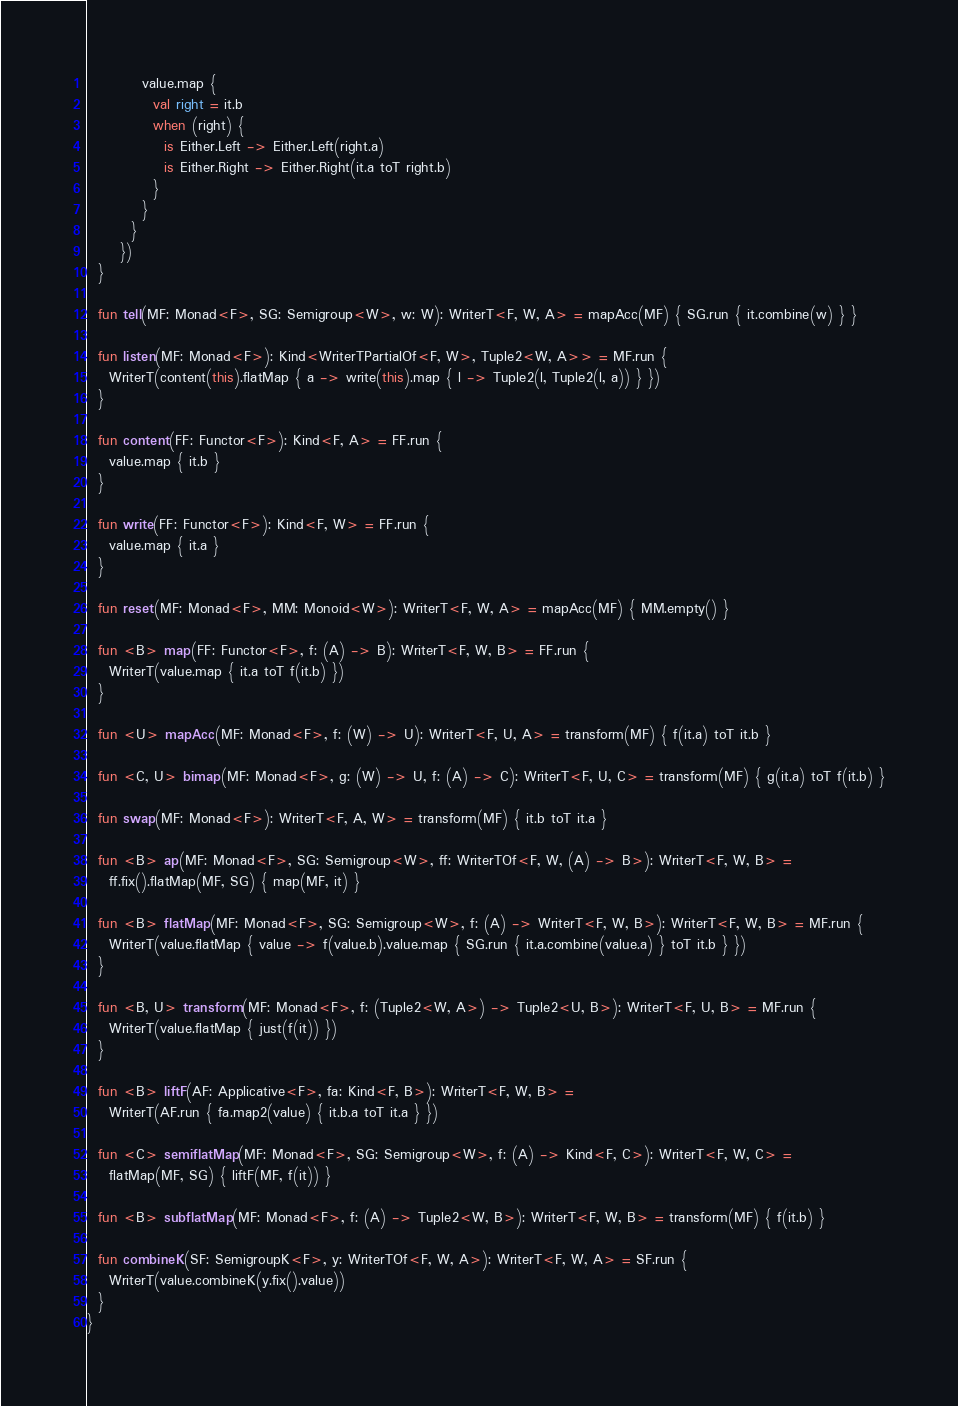<code> <loc_0><loc_0><loc_500><loc_500><_Kotlin_>          value.map {
            val right = it.b
            when (right) {
              is Either.Left -> Either.Left(right.a)
              is Either.Right -> Either.Right(it.a toT right.b)
            }
          }
        }
      })
  }

  fun tell(MF: Monad<F>, SG: Semigroup<W>, w: W): WriterT<F, W, A> = mapAcc(MF) { SG.run { it.combine(w) } }

  fun listen(MF: Monad<F>): Kind<WriterTPartialOf<F, W>, Tuple2<W, A>> = MF.run {
    WriterT(content(this).flatMap { a -> write(this).map { l -> Tuple2(l, Tuple2(l, a)) } })
  }

  fun content(FF: Functor<F>): Kind<F, A> = FF.run {
    value.map { it.b }
  }

  fun write(FF: Functor<F>): Kind<F, W> = FF.run {
    value.map { it.a }
  }

  fun reset(MF: Monad<F>, MM: Monoid<W>): WriterT<F, W, A> = mapAcc(MF) { MM.empty() }

  fun <B> map(FF: Functor<F>, f: (A) -> B): WriterT<F, W, B> = FF.run {
    WriterT(value.map { it.a toT f(it.b) })
  }

  fun <U> mapAcc(MF: Monad<F>, f: (W) -> U): WriterT<F, U, A> = transform(MF) { f(it.a) toT it.b }

  fun <C, U> bimap(MF: Monad<F>, g: (W) -> U, f: (A) -> C): WriterT<F, U, C> = transform(MF) { g(it.a) toT f(it.b) }

  fun swap(MF: Monad<F>): WriterT<F, A, W> = transform(MF) { it.b toT it.a }

  fun <B> ap(MF: Monad<F>, SG: Semigroup<W>, ff: WriterTOf<F, W, (A) -> B>): WriterT<F, W, B> =
    ff.fix().flatMap(MF, SG) { map(MF, it) }

  fun <B> flatMap(MF: Monad<F>, SG: Semigroup<W>, f: (A) -> WriterT<F, W, B>): WriterT<F, W, B> = MF.run {
    WriterT(value.flatMap { value -> f(value.b).value.map { SG.run { it.a.combine(value.a) } toT it.b } })
  }

  fun <B, U> transform(MF: Monad<F>, f: (Tuple2<W, A>) -> Tuple2<U, B>): WriterT<F, U, B> = MF.run {
    WriterT(value.flatMap { just(f(it)) })
  }

  fun <B> liftF(AF: Applicative<F>, fa: Kind<F, B>): WriterT<F, W, B> =
    WriterT(AF.run { fa.map2(value) { it.b.a toT it.a } })

  fun <C> semiflatMap(MF: Monad<F>, SG: Semigroup<W>, f: (A) -> Kind<F, C>): WriterT<F, W, C> =
    flatMap(MF, SG) { liftF(MF, f(it)) }

  fun <B> subflatMap(MF: Monad<F>, f: (A) -> Tuple2<W, B>): WriterT<F, W, B> = transform(MF) { f(it.b) }

  fun combineK(SF: SemigroupK<F>, y: WriterTOf<F, W, A>): WriterT<F, W, A> = SF.run {
    WriterT(value.combineK(y.fix().value))
  }
}
</code> 